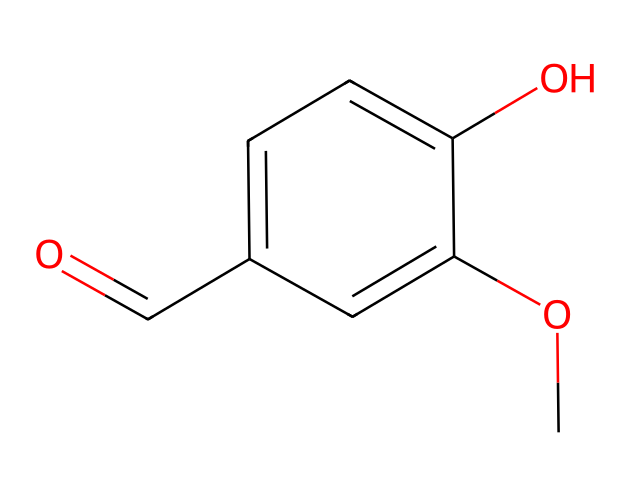What is the molecular formula of vanillin? The SMILES representation denotes the presence of carbon (C), hydrogen (H), and oxygen (O) atoms. Counting these, there are eight carbon atoms, eight hydrogen atoms, and three oxygen atoms in the structure. Thus, the molecular formula is C8H8O3.
Answer: C8H8O3 How many hydroxyl (–OH) groups are present in vanillin? The structure indicates there is one hydroxyl group, represented by the "O" connected to a hydrogen atom in the chemical. This characteristic is essential to the classification of phenols.
Answer: one Does vanillin contain an aldehyde functional group? The presence of the carbonyl (C=O) attached to a carbon atom at the end of the molecule indicates an aldehyde functional group. This can be specifically recognized in the C=O bond connected to the benzene ring.
Answer: yes What type of aromatic ring is present in vanillin? The benzene ring consists of six carbon atoms arranged in a ring, accompanied by alternating single and double bonds. This structure is typical of aromatic compounds.
Answer: benzene How many total atoms are in the vanillin molecule? By adding the number of each atom based on its molecular formula (8 carbons + 8 hydrogens + 3 oxygens), the total equals 19 atoms.
Answer: 19 What does the methoxy group (–OCH3) in vanillin signify? The methoxy group, denoted by "CO" in the SMILES structure, signifies that the compound has a methyl group attached to an oxygen atom, which is a feature typical for phenolic compounds and contributes to the flavor profile of vanillin.
Answer: aromatic ether Is vanillin classified as a phenol? Since vanillin contains a hydroxyl group (-OH) bonded directly to an aromatic ring, it meets the criteria for classification as a phenol. The hydroxyl group's position contributes to the unique properties of vanillin.
Answer: yes 